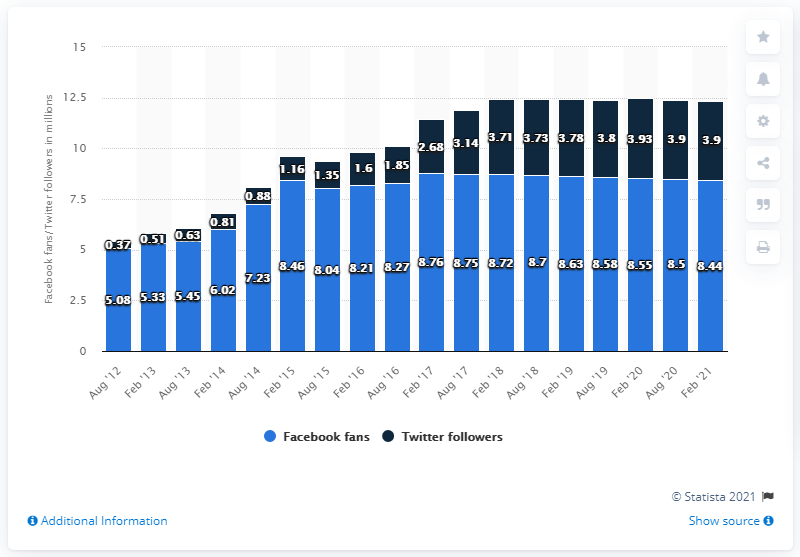Identify some key points in this picture. In February 2021, the Dallas Cowboys football team had 8,440 Facebook fans. 